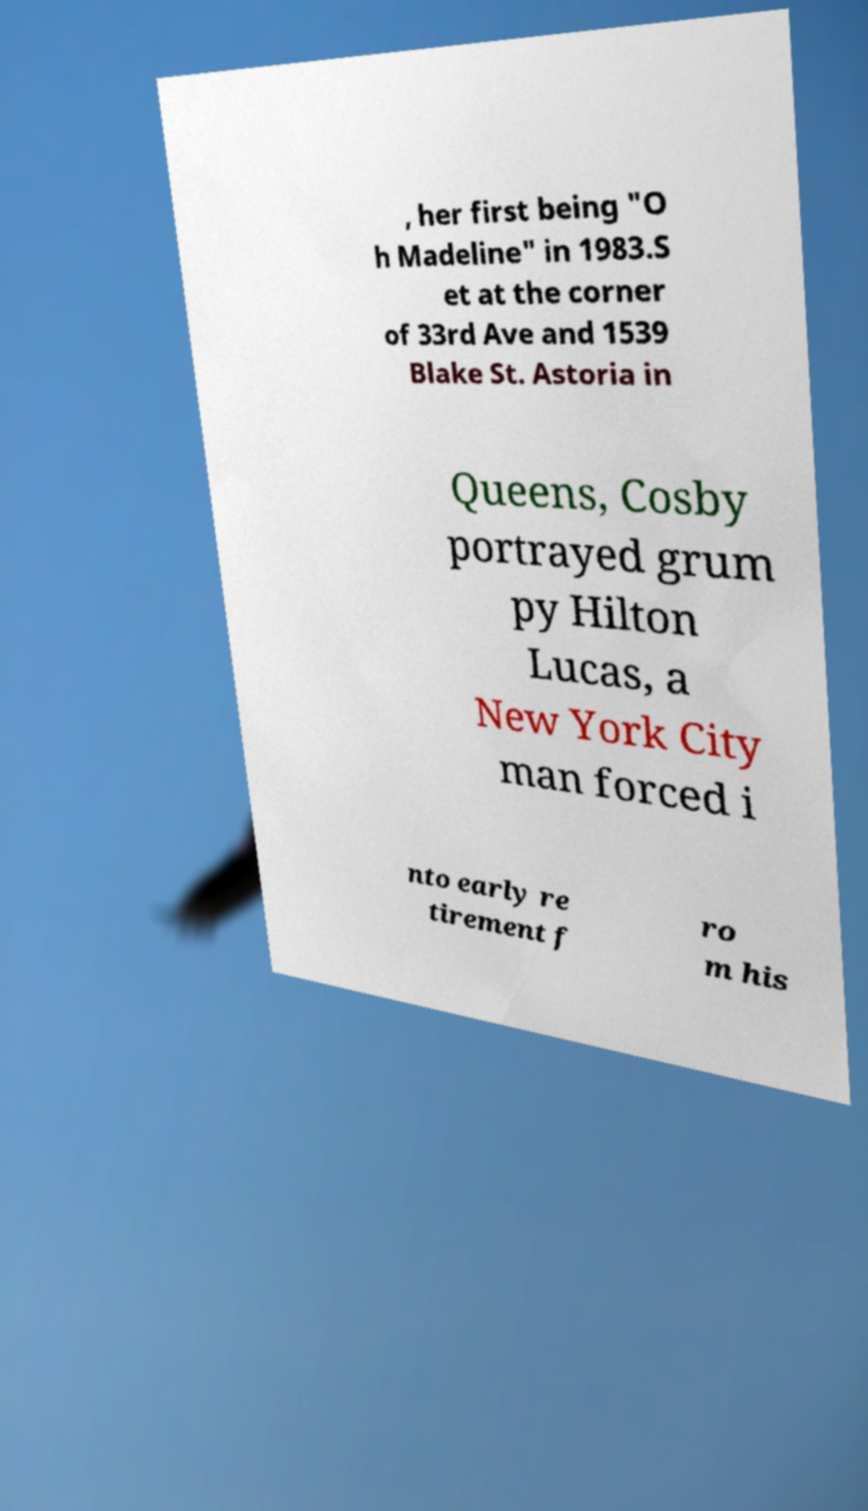I need the written content from this picture converted into text. Can you do that? , her first being "O h Madeline" in 1983.S et at the corner of 33rd Ave and 1539 Blake St. Astoria in Queens, Cosby portrayed grum py Hilton Lucas, a New York City man forced i nto early re tirement f ro m his 